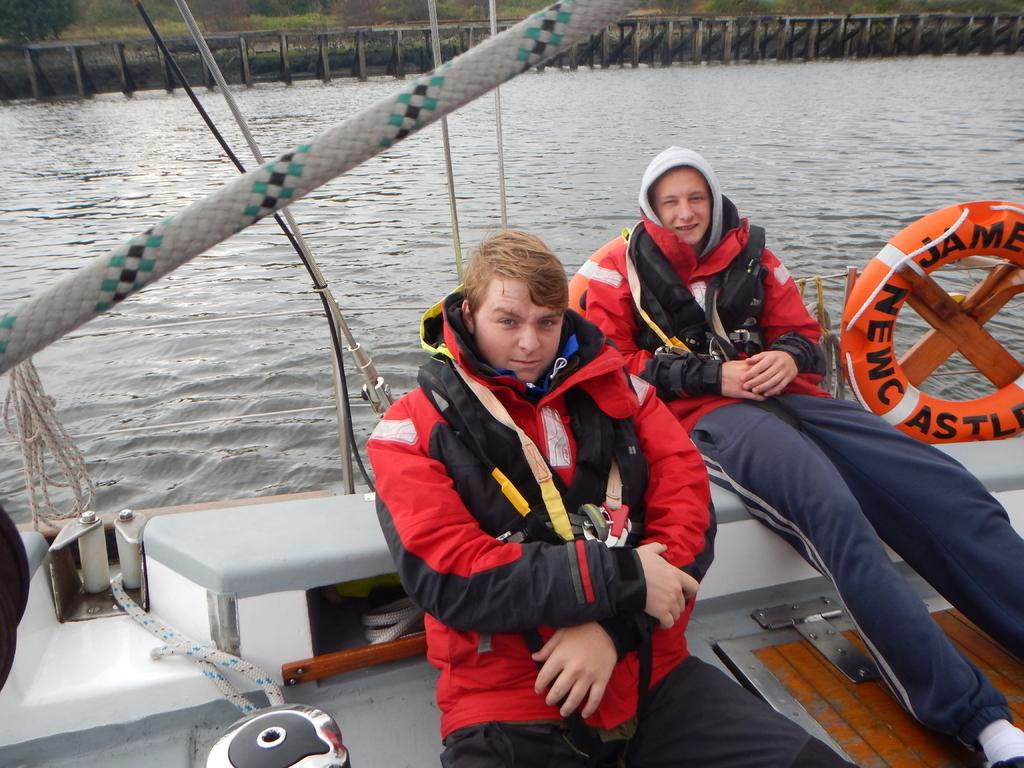How many people are in the image? There are two persons in the image. What are the persons wearing? The persons are wearing red life jackets. Where are the persons sitting? The persons are sitting on a boat. What body of water is the boat in? The boat is in a river. What can be seen in the background of the image? There appears to be a bridge in the background of the image. What type of bear can be seen interacting with the persons on the boat? There is no bear present in the image; the persons are wearing red life jackets and sitting on a boat in a river. How does the earthquake affect the boat in the image? There is no earthquake present in the image; the boat is in a river with two persons wearing red life jackets. 